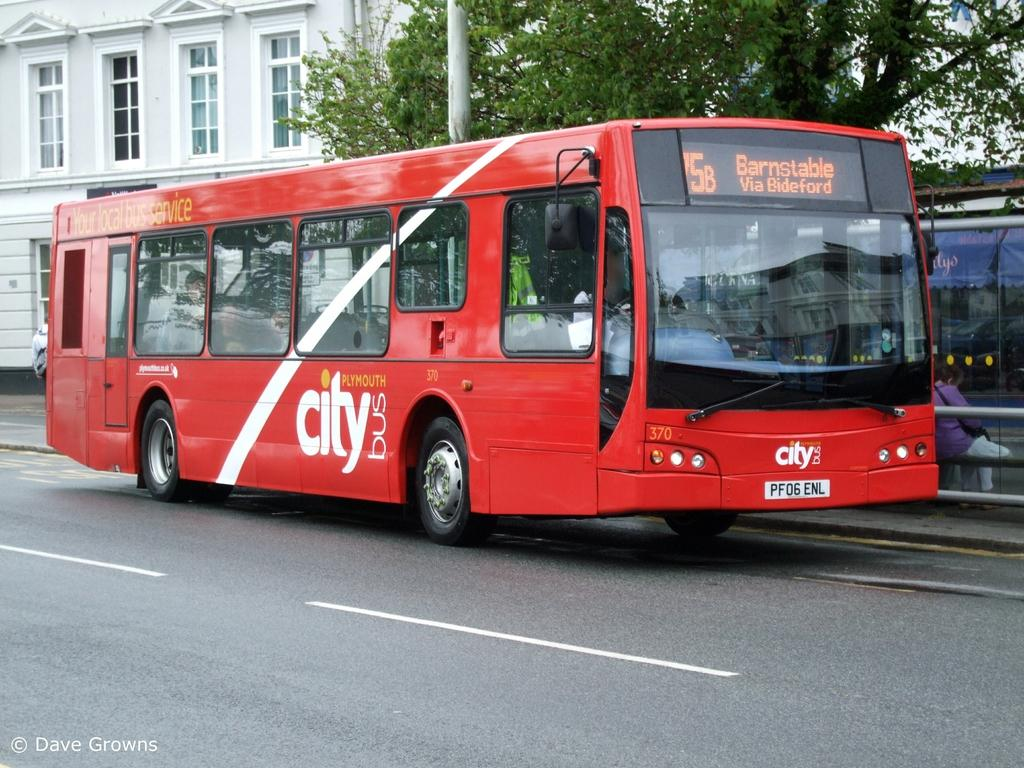<image>
Create a compact narrative representing the image presented. A red Plymouth City Bus is on a public street. 